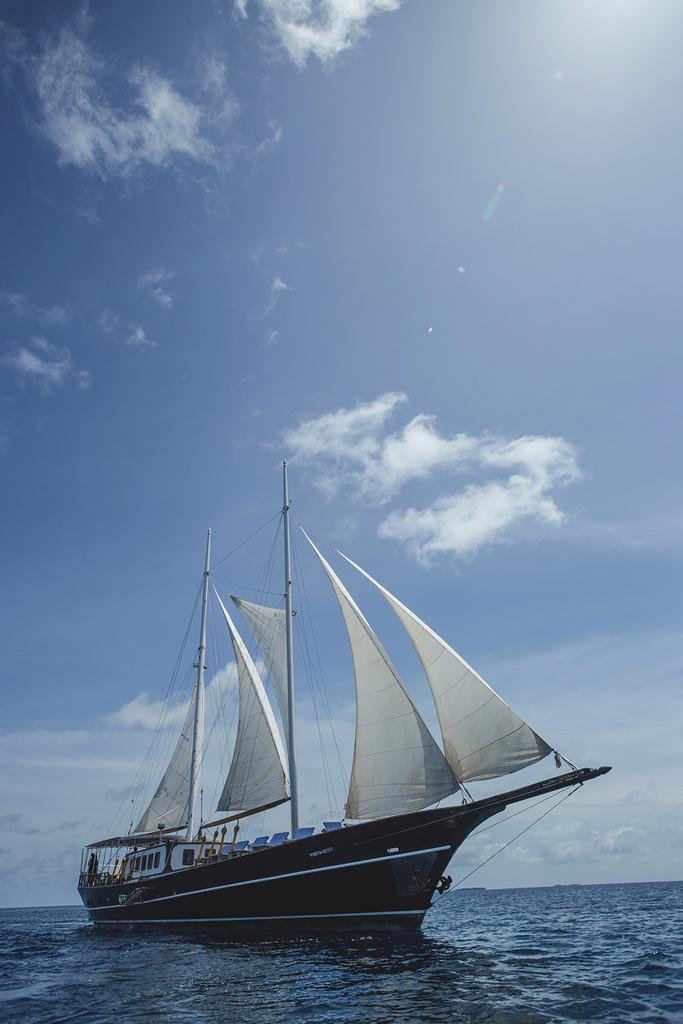Can you describe this image briefly? In this picture we can see a boat on the water. There are a few poles, sails and other objects are visible on this boat. Sky is blue in color and cloudy. 